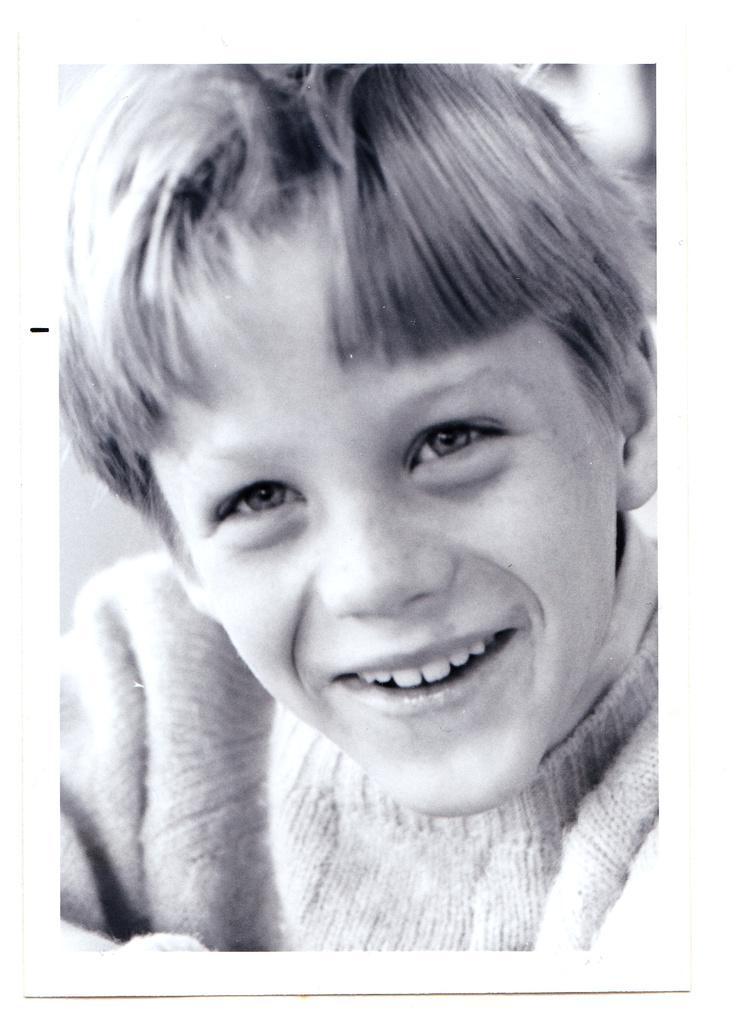In one or two sentences, can you explain what this image depicts? In the image a boy is smiling. 